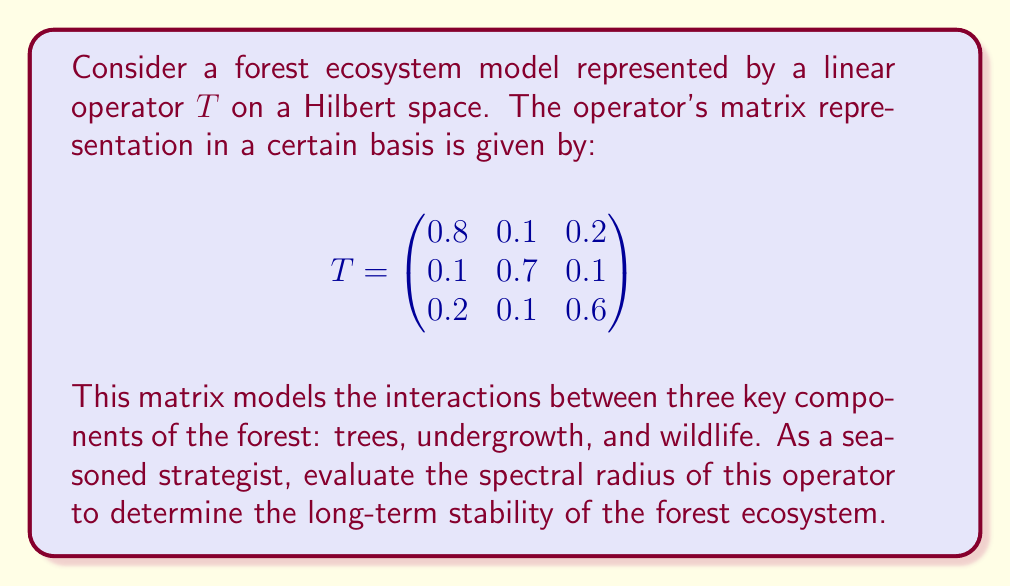What is the answer to this math problem? To evaluate the spectral radius of the operator $T$, we follow these steps:

1) The spectral radius $\rho(T)$ is defined as:
   $$\rho(T) = \max\{|\lambda| : \lambda \text{ is an eigenvalue of } T\}$$

2) To find the eigenvalues, we solve the characteristic equation:
   $$\det(T - \lambda I) = 0$$

3) Expanding the determinant:
   $$\begin{vmatrix}
   0.8-\lambda & 0.1 & 0.2 \\
   0.1 & 0.7-\lambda & 0.1 \\
   0.2 & 0.1 & 0.6-\lambda
   \end{vmatrix} = 0$$

4) This yields the characteristic polynomial:
   $$-\lambda^3 + 2.1\lambda^2 - 1.41\lambda + 0.308 = 0$$

5) Using the cubic formula or numerical methods, we find the roots:
   $$\lambda_1 \approx 0.9962, \lambda_2 \approx 0.5519, \lambda_3 \approx 0.5519$$

6) The spectral radius is the maximum absolute value of these eigenvalues:
   $$\rho(T) = \max\{|0.9962|, |0.5519|, |0.5519|\} = 0.9962$$

7) Since $\rho(T) < 1$, the ecosystem model is stable, but very close to the stability threshold.
Answer: The spectral radius of the operator $T$ is $\rho(T) = 0.9962$. 